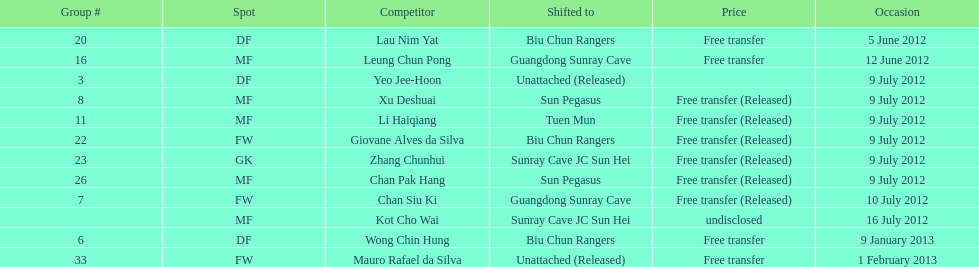Would you be able to parse every entry in this table? {'header': ['Group #', 'Spot', 'Competitor', 'Shifted to', 'Price', 'Occasion'], 'rows': [['20', 'DF', 'Lau Nim Yat', 'Biu Chun Rangers', 'Free transfer', '5 June 2012'], ['16', 'MF', 'Leung Chun Pong', 'Guangdong Sunray Cave', 'Free transfer', '12 June 2012'], ['3', 'DF', 'Yeo Jee-Hoon', 'Unattached (Released)', '', '9 July 2012'], ['8', 'MF', 'Xu Deshuai', 'Sun Pegasus', 'Free transfer (Released)', '9 July 2012'], ['11', 'MF', 'Li Haiqiang', 'Tuen Mun', 'Free transfer (Released)', '9 July 2012'], ['22', 'FW', 'Giovane Alves da Silva', 'Biu Chun Rangers', 'Free transfer (Released)', '9 July 2012'], ['23', 'GK', 'Zhang Chunhui', 'Sunray Cave JC Sun Hei', 'Free transfer (Released)', '9 July 2012'], ['26', 'MF', 'Chan Pak Hang', 'Sun Pegasus', 'Free transfer (Released)', '9 July 2012'], ['7', 'FW', 'Chan Siu Ki', 'Guangdong Sunray Cave', 'Free transfer (Released)', '10 July 2012'], ['', 'MF', 'Kot Cho Wai', 'Sunray Cave JC Sun Hei', 'undisclosed', '16 July 2012'], ['6', 'DF', 'Wong Chin Hung', 'Biu Chun Rangers', 'Free transfer', '9 January 2013'], ['33', 'FW', 'Mauro Rafael da Silva', 'Unattached (Released)', 'Free transfer', '1 February 2013']]} On what dates were there non released free transfers? 5 June 2012, 12 June 2012, 9 January 2013, 1 February 2013. On which of these were the players transferred to another team? 5 June 2012, 12 June 2012, 9 January 2013. Which of these were the transfers to biu chun rangers? 5 June 2012, 9 January 2013. On which of those dated did they receive a df? 9 January 2013. 